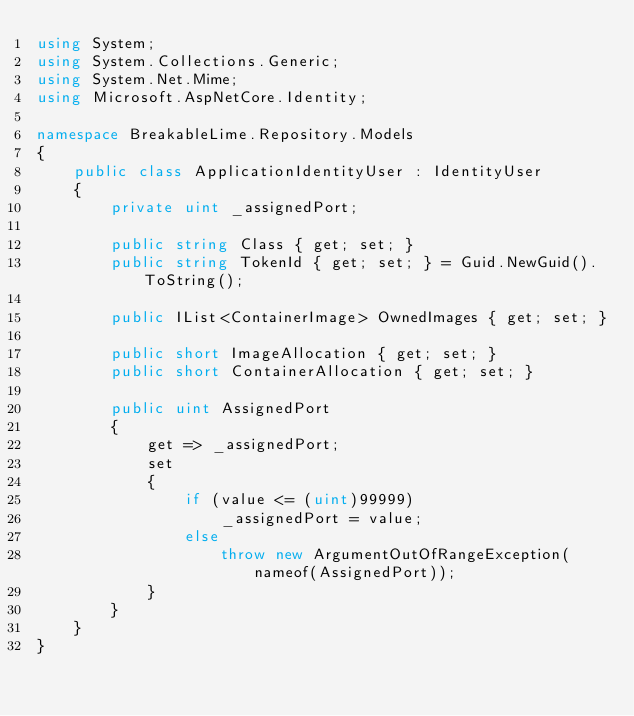<code> <loc_0><loc_0><loc_500><loc_500><_C#_>using System;
using System.Collections.Generic;
using System.Net.Mime;
using Microsoft.AspNetCore.Identity;

namespace BreakableLime.Repository.Models
{
    public class ApplicationIdentityUser : IdentityUser
    {
        private uint _assignedPort;
        
        public string Class { get; set; }
        public string TokenId { get; set; } = Guid.NewGuid().ToString();
        
        public IList<ContainerImage> OwnedImages { get; set; }
        
        public short ImageAllocation { get; set; }
        public short ContainerAllocation { get; set; }

        public uint AssignedPort
        {
            get => _assignedPort;
            set
            {
                if (value <= (uint)99999)
                    _assignedPort = value;
                else
                    throw new ArgumentOutOfRangeException(nameof(AssignedPort));
            }
        }
    }
}</code> 